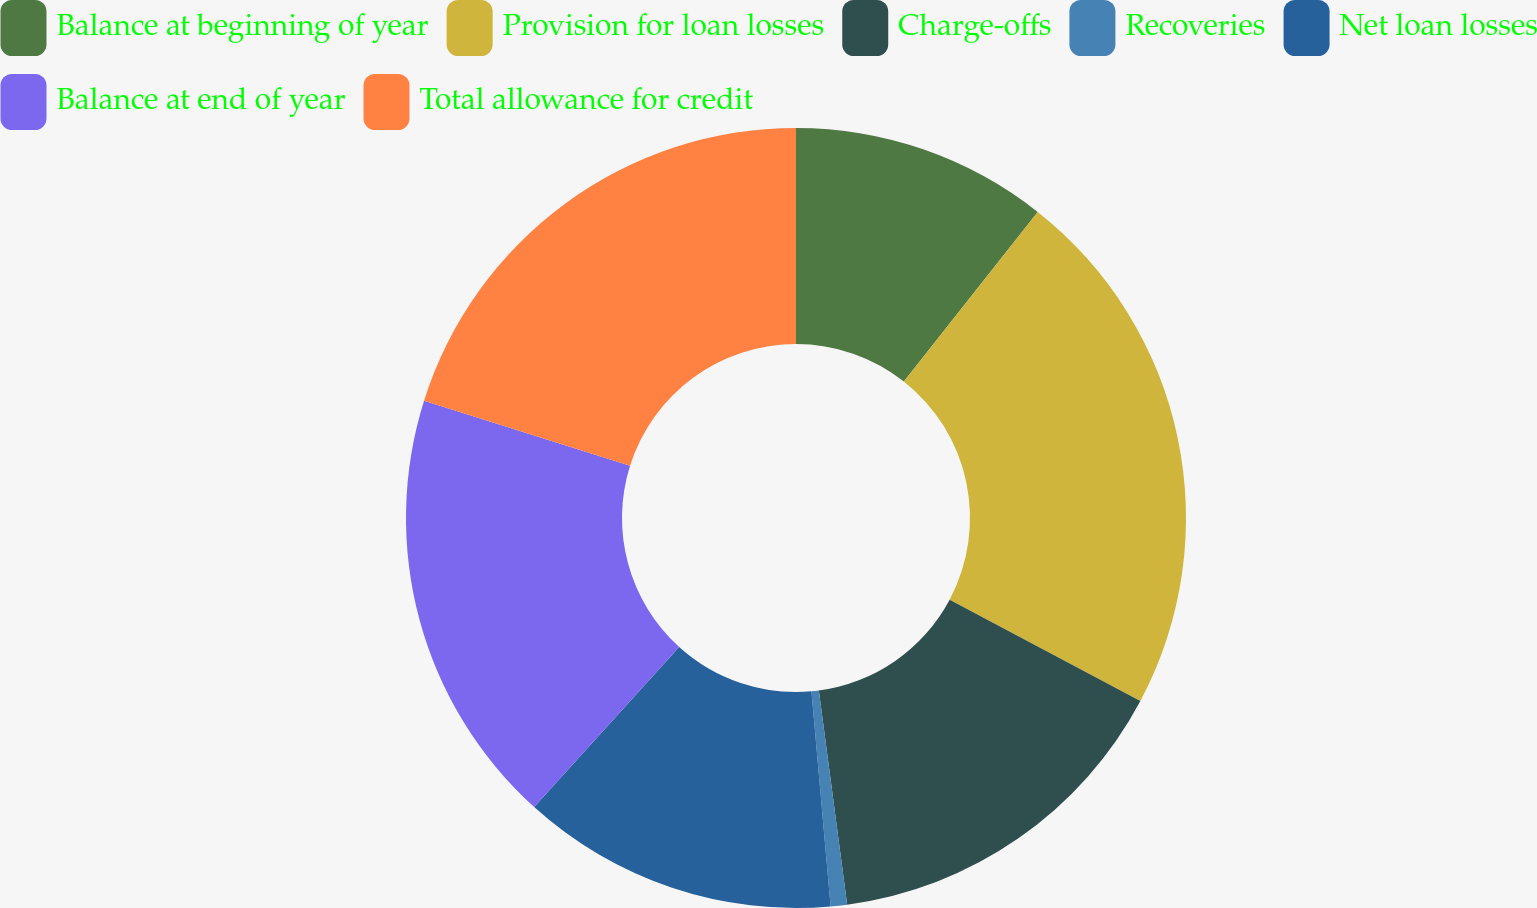<chart> <loc_0><loc_0><loc_500><loc_500><pie_chart><fcel>Balance at beginning of year<fcel>Provision for loan losses<fcel>Charge-offs<fcel>Recoveries<fcel>Net loan losses<fcel>Balance at end of year<fcel>Total allowance for credit<nl><fcel>10.64%<fcel>22.14%<fcel>15.13%<fcel>0.68%<fcel>13.13%<fcel>18.15%<fcel>20.14%<nl></chart> 